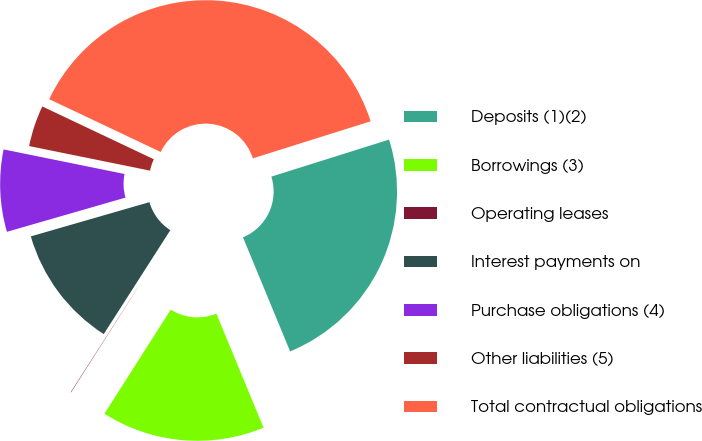<chart> <loc_0><loc_0><loc_500><loc_500><pie_chart><fcel>Deposits (1)(2)<fcel>Borrowings (3)<fcel>Operating leases<fcel>Interest payments on<fcel>Purchase obligations (4)<fcel>Other liabilities (5)<fcel>Total contractual obligations<nl><fcel>23.61%<fcel>15.27%<fcel>0.04%<fcel>11.46%<fcel>7.66%<fcel>3.85%<fcel>38.11%<nl></chart> 